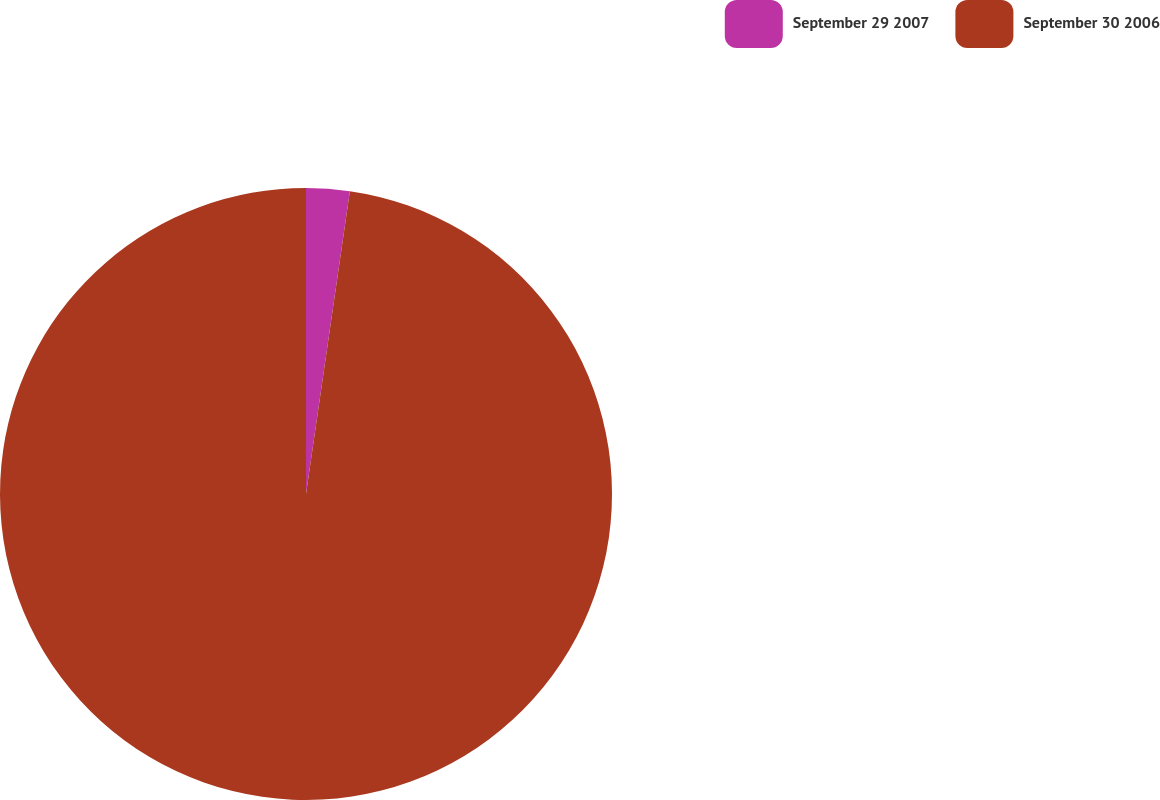<chart> <loc_0><loc_0><loc_500><loc_500><pie_chart><fcel>September 29 2007<fcel>September 30 2006<nl><fcel>2.29%<fcel>97.71%<nl></chart> 